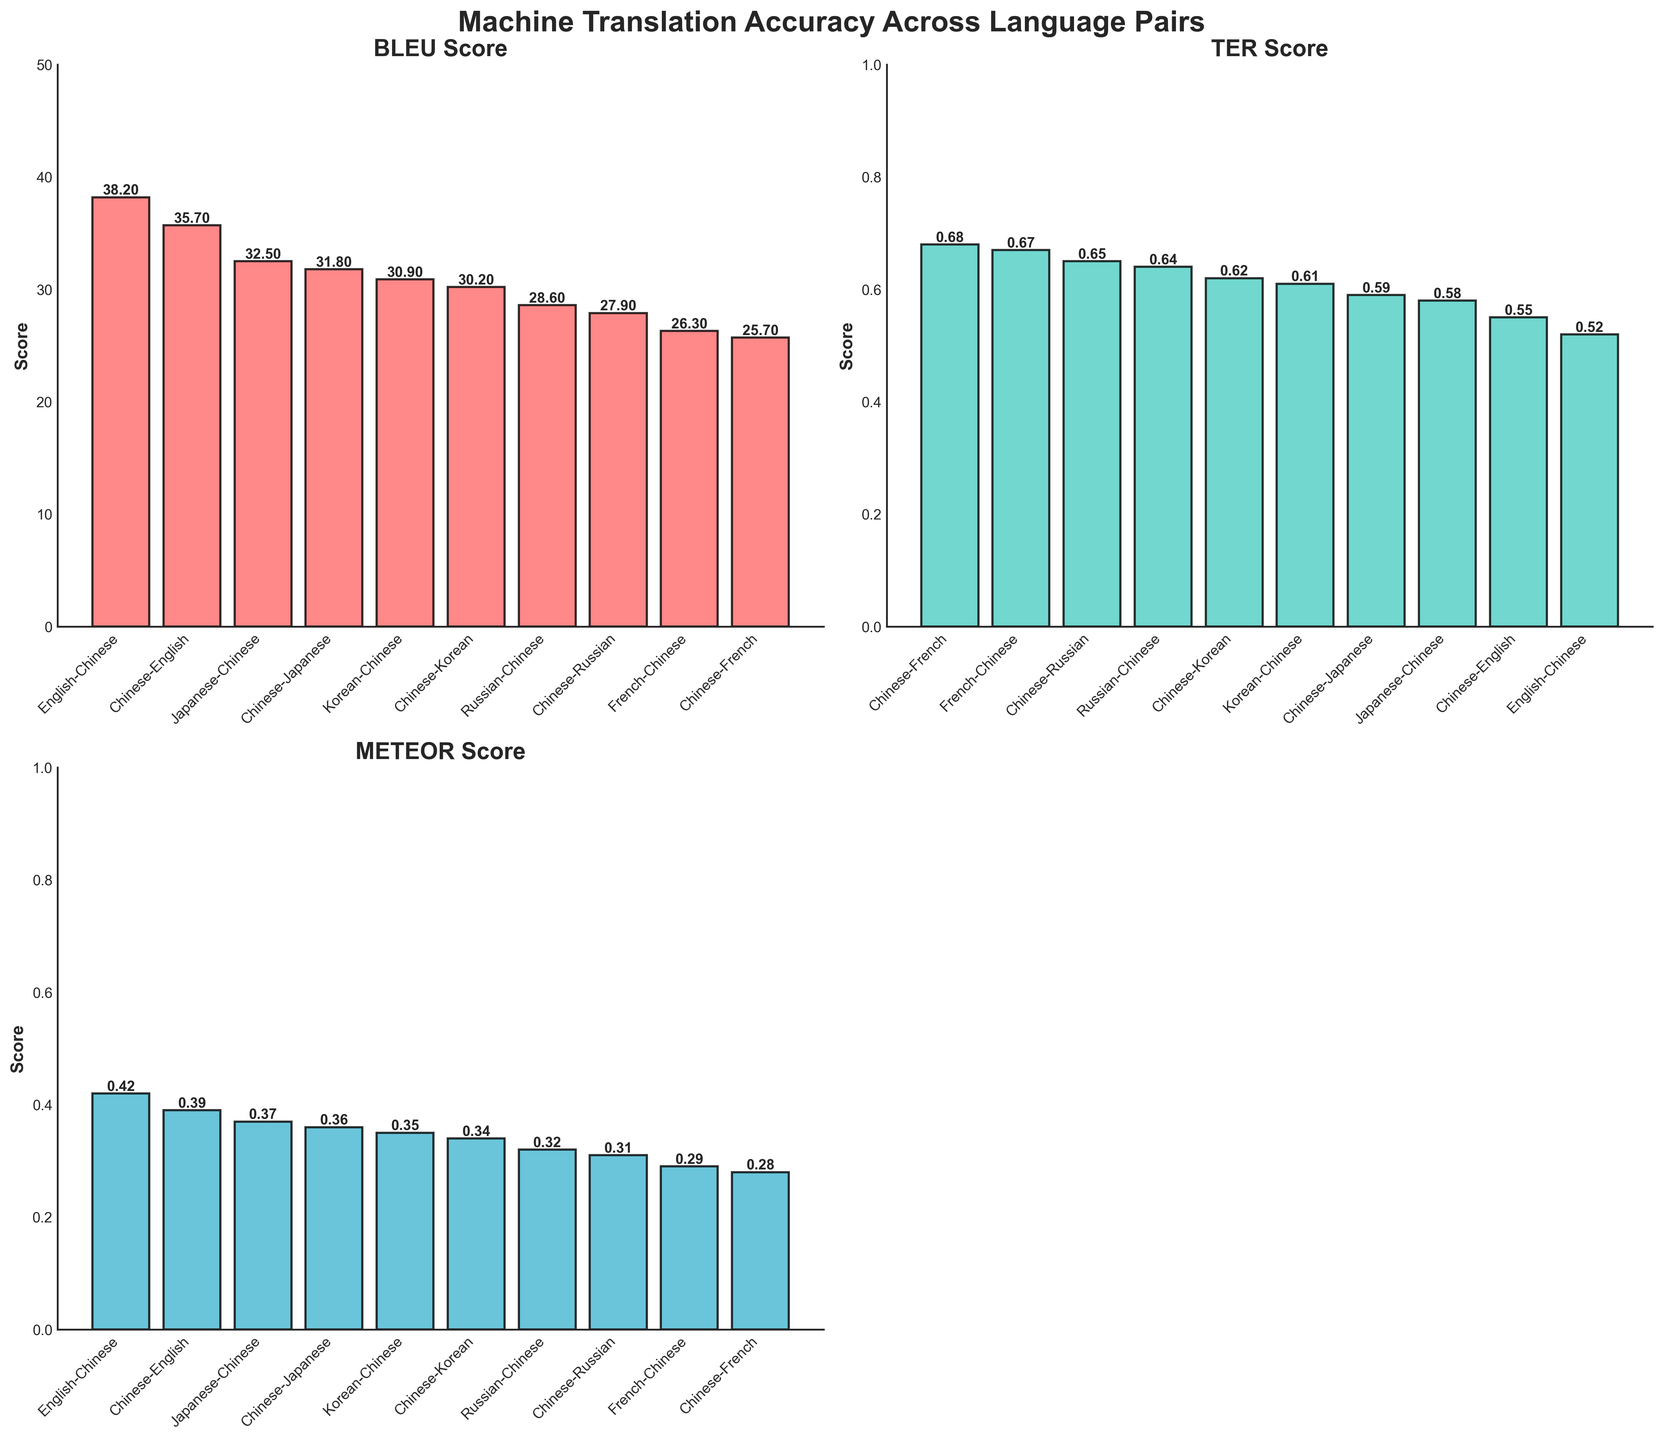What is the title of the figure? The title of the figure is written at the top. It reads "Machine Translation Accuracy Across Language Pairs".
Answer: Machine Translation Accuracy Across Language Pairs Which language pair has the highest BLEU Score? The BLEU Score subplot ranks the language pairs from highest to lowest, with the highest value at the leftmost bar. The language pair with the highest BLEU Score is "English-Chinese" with a score of 38.2.
Answer: English-Chinese How do the TER Scores compare between Chinese-Korean and Japanese-Chinese? To compare the TER Scores between Chinese-Korean and Japanese-Chinese, look at the heights of the bars in the TER Score subplot. The bar for Japanese-Chinese is taller than the bar for Chinese-Korean, indicating a higher TER Score. Specifically, Japanese-Chinese has a TER Score of 0.58, and Chinese-Korean has a TER Score of 0.62.
Answer: Chinese-Korean has a higher TER Score than Japanese-Chinese What is the average METEOR Score for language pairs involving Chinese? To calculate the average METEOR Score for language pairs involving Chinese, sum the METEOR Scores for all Chinese pairs and divide by the number of pairs. The METEOR Scores are: 0.42, 0.39, 0.37, 0.36, 0.35, 0.34, 0.32, 0.31, 0.29, 0.28. The total sum is 3.43, divided by 10 pairs gives an average of 0.343.
Answer: 0.343 Which metric has the lowest score for the language pair "Chinese-French"? To find the lowest score for "Chinese-French," examine the subplots for each metric. The METEOR Score subplot shows that "Chinese-French" has a METEOR Score of 0.28, which is lower than its TER Score (0.68) and BLEU Score (25.7).
Answer: METEOR Score What is the total number of language pairs involving Chinese? Count the number of bars in any subplot since they all represent the same data set of language pairs involving Chinese. There are 10 bars in each subplot, indicating 10 language pairs.
Answer: 10 How much higher is the BLEU Score for English-Chinese compared to Chinese-Russian? Subtract the BLEU Score of Chinese-Russian from that of English-Chinese. English-Chinese has a BLEU Score of 38.2, and Chinese-Russian has a BLEU Score of 27.9. The difference is 38.2 - 27.9 = 10.3.
Answer: 10.3 Which language pair has the lowest TER Score? The TER Score for each language pair is shown in the TER Score subplot. The language pair with the lowest TER Score is "English-Chinese," with a score of 0.52.
Answer: English-Chinese What is the sum of the TER Scores for Chinese-Korean and Chinese-French? The sum of the TER Scores for Chinese-Korean (0.62) and Chinese-French (0.68) is calculated as 0.62 + 0.68 = 1.3.
Answer: 1.3 